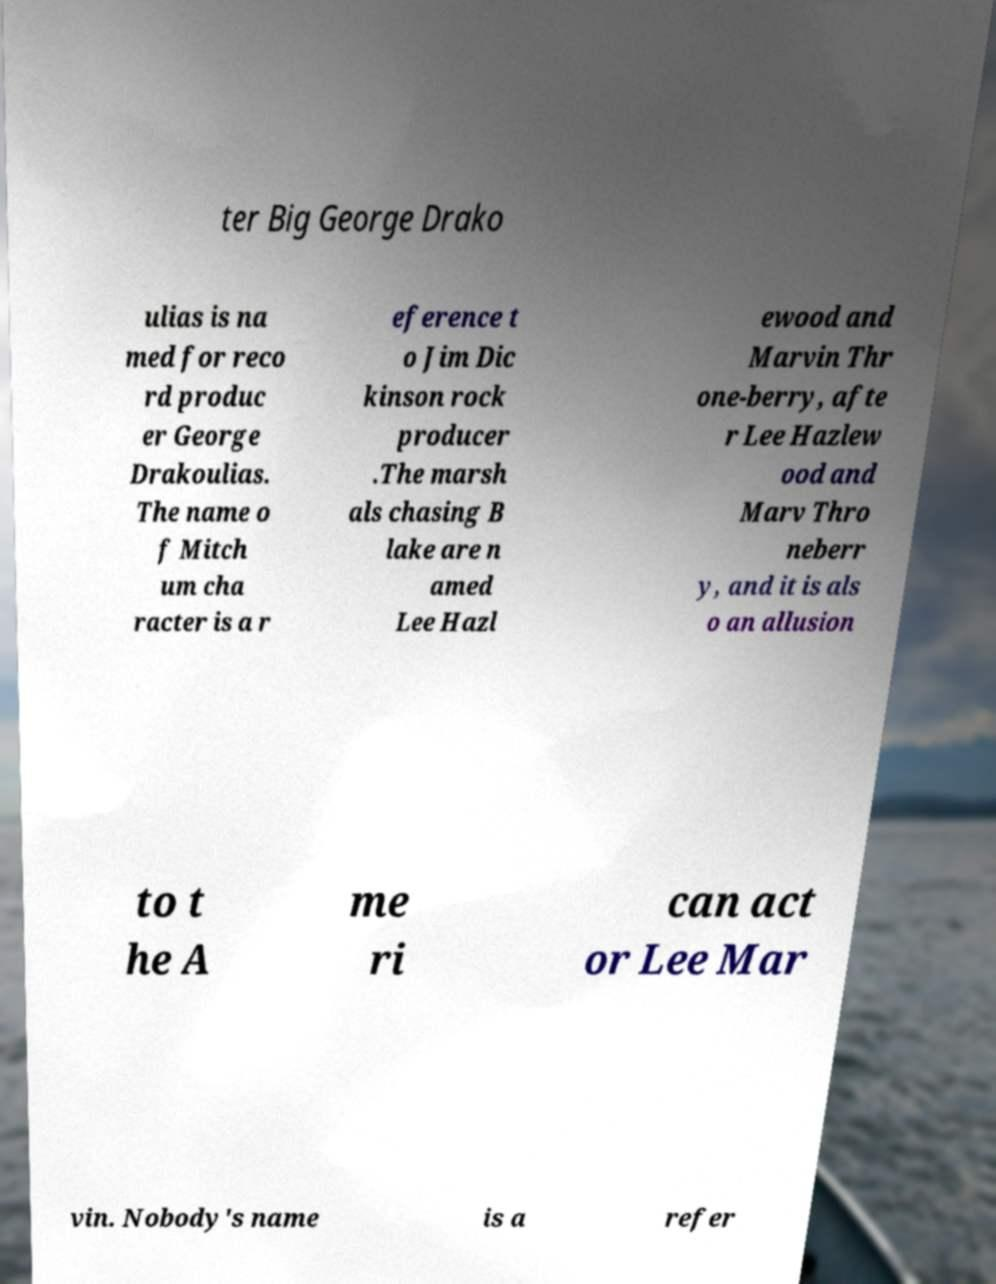I need the written content from this picture converted into text. Can you do that? ter Big George Drako ulias is na med for reco rd produc er George Drakoulias. The name o f Mitch um cha racter is a r eference t o Jim Dic kinson rock producer .The marsh als chasing B lake are n amed Lee Hazl ewood and Marvin Thr one-berry, afte r Lee Hazlew ood and Marv Thro neberr y, and it is als o an allusion to t he A me ri can act or Lee Mar vin. Nobody's name is a refer 